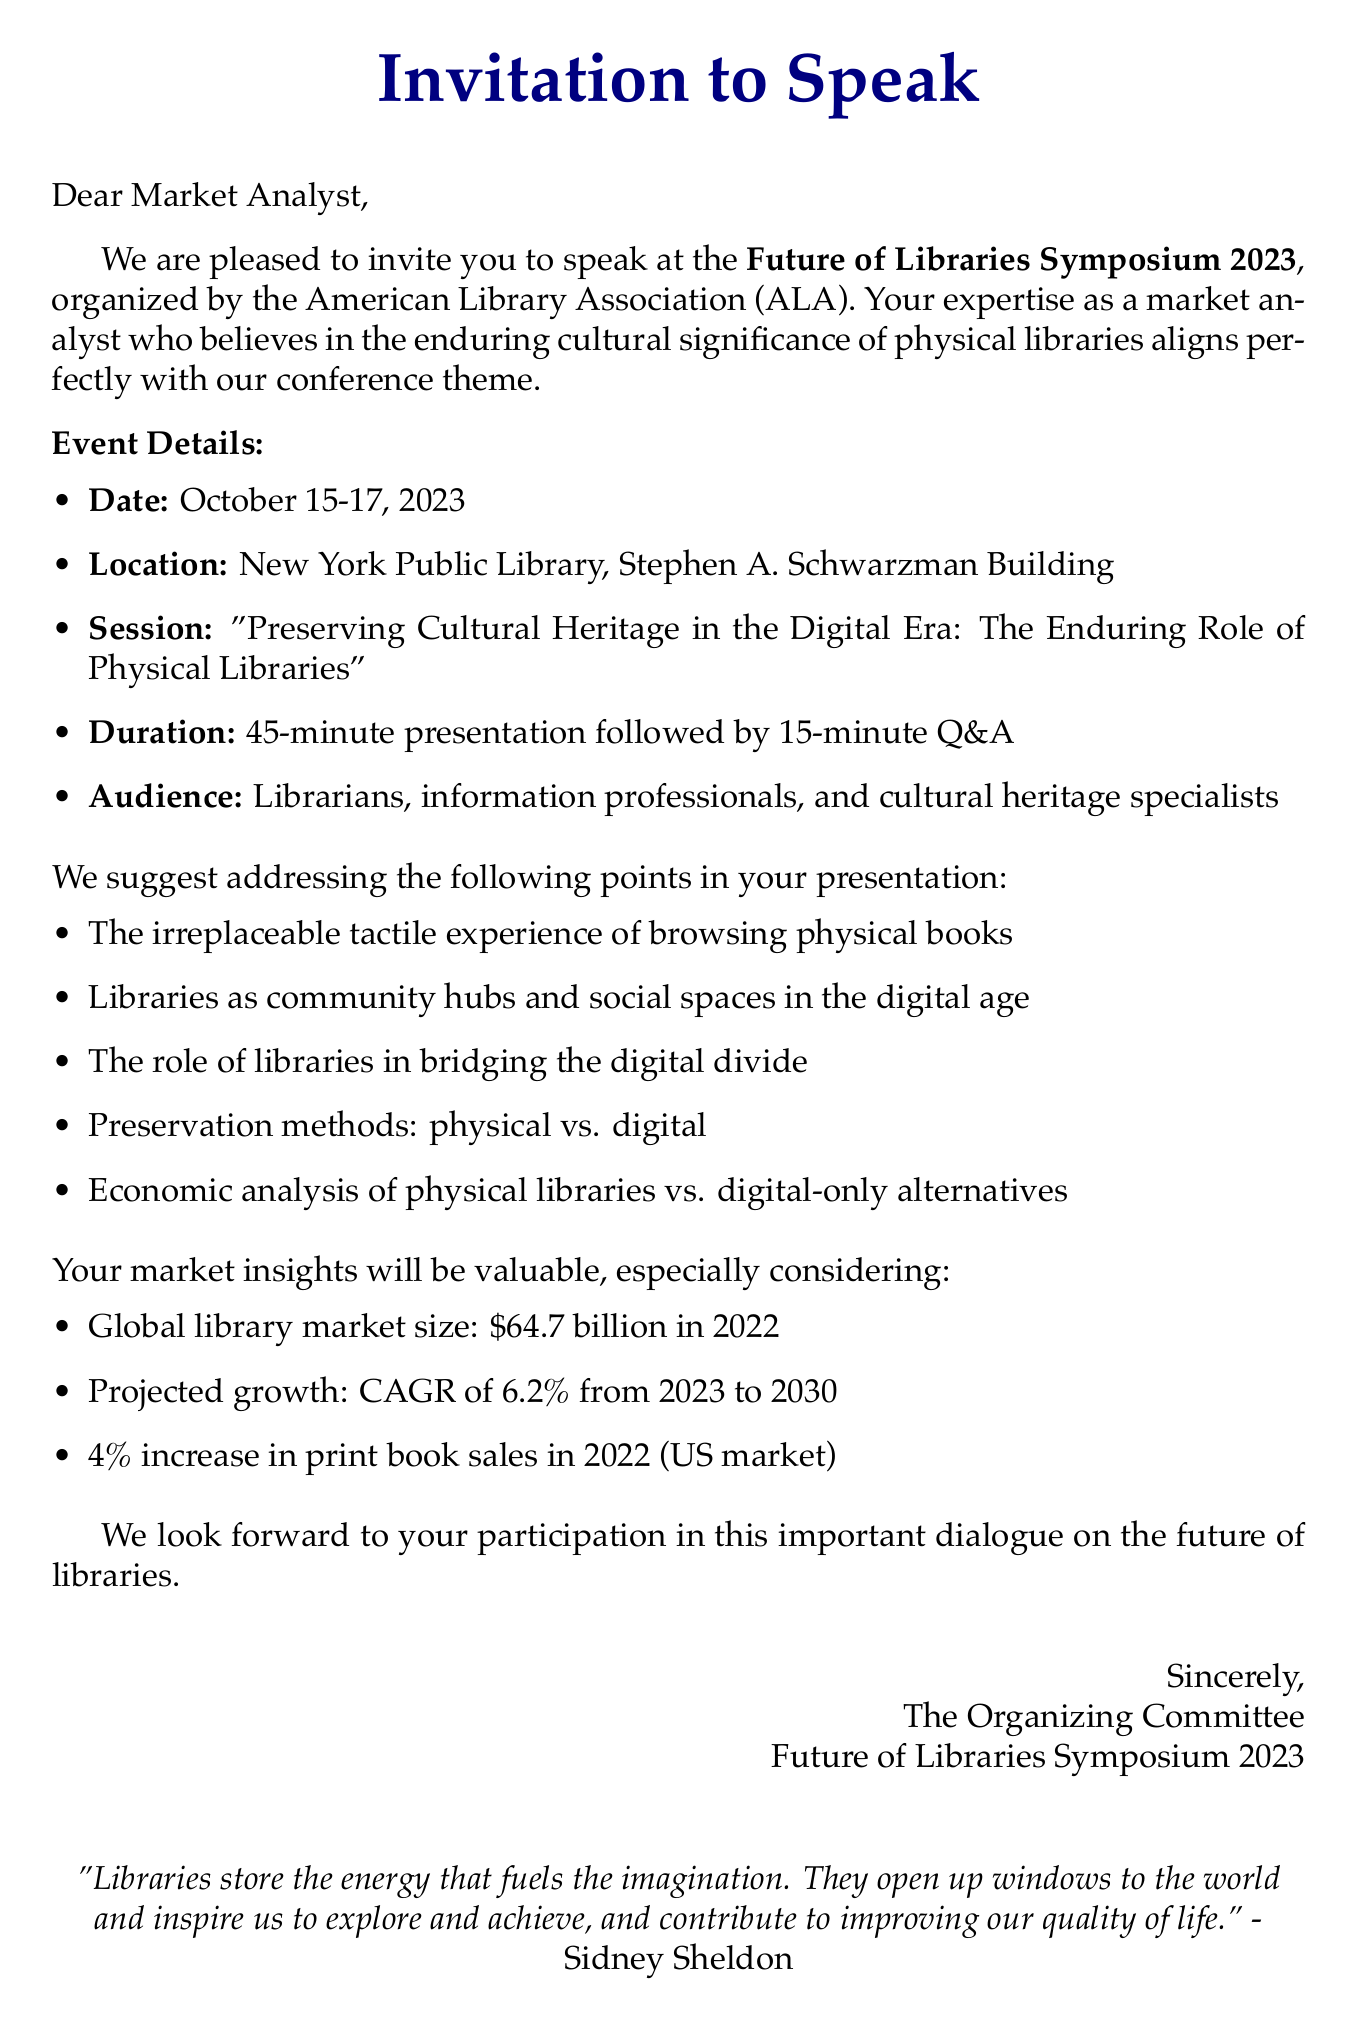What is the conference name? The document explicitly states the name of the conference being referred to, which is given as "Future of Libraries Symposium 2023."
Answer: Future of Libraries Symposium 2023 What are the dates of the conference? The document lists the specific dates of the conference, which are indicated as "October 15-17, 2023."
Answer: October 15-17, 2023 Where is the conference being held? The location of the conference is provided in the document and can be found within the event details section: "New York Public Library, Stephen A. Schwarzman Building."
Answer: New York Public Library, Stephen A. Schwarzman Building What is the session title? The title of the session for which the speaker is invited is clearly stated in the invitation: "Preserving Cultural Heritage in the Digital Era: The Enduring Role of Physical Libraries."
Answer: Preserving Cultural Heritage in the Digital Era: The Enduring Role of Physical Libraries What is the projected growth rate of the global library market from 2023 to 2030? The document presents the projected growth of the market as a percentage, so the specific figure can be noted from relevant market data: "CAGR of 6.2% from 2023 to 2030."
Answer: 6.2% Why might the economic analysis of physical libraries versus digital-only alternatives be relevant? The document suggests that the evaluation of economic aspects regarding libraries will help contextually compare the costs and values, aligning with concerns of the target audience about library roles.
Answer: To compare costs and values 